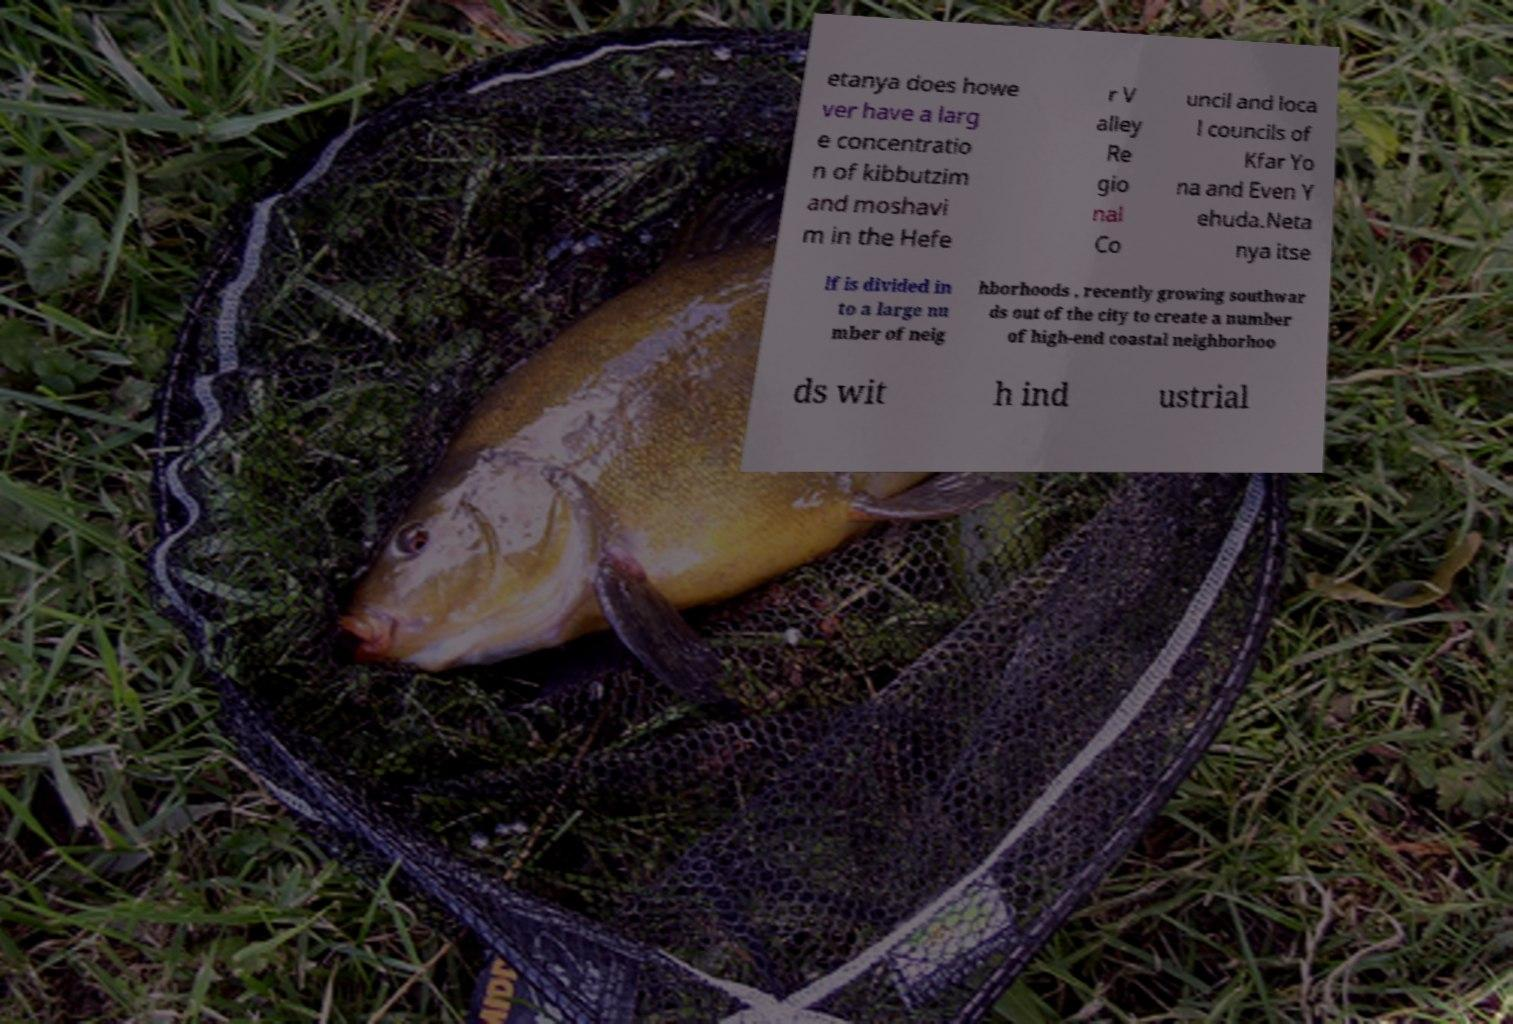Could you extract and type out the text from this image? etanya does howe ver have a larg e concentratio n of kibbutzim and moshavi m in the Hefe r V alley Re gio nal Co uncil and loca l councils of Kfar Yo na and Even Y ehuda.Neta nya itse lf is divided in to a large nu mber of neig hborhoods , recently growing southwar ds out of the city to create a number of high-end coastal neighborhoo ds wit h ind ustrial 